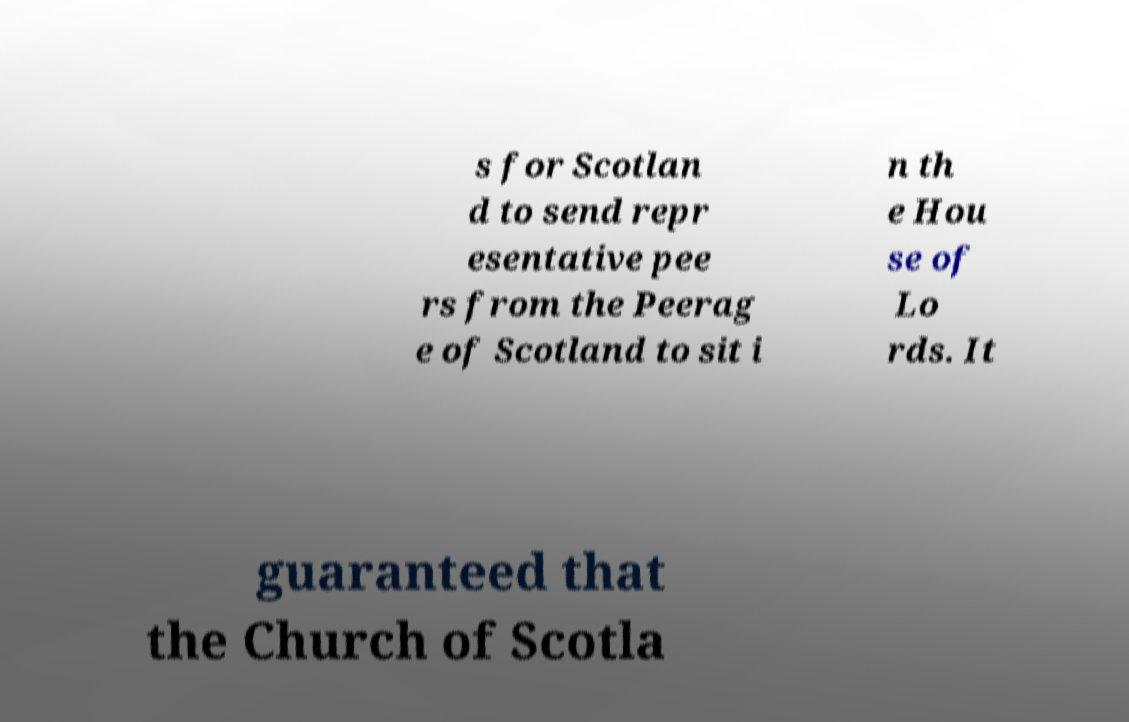Could you extract and type out the text from this image? s for Scotlan d to send repr esentative pee rs from the Peerag e of Scotland to sit i n th e Hou se of Lo rds. It guaranteed that the Church of Scotla 